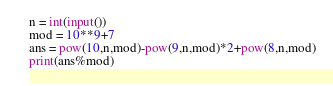<code> <loc_0><loc_0><loc_500><loc_500><_Python_>n = int(input())
mod = 10**9+7
ans = pow(10,n,mod)-pow(9,n,mod)*2+pow(8,n,mod)
print(ans%mod)</code> 